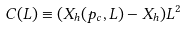<formula> <loc_0><loc_0><loc_500><loc_500>C ( L ) \equiv ( X _ { h } ( p _ { c } , L ) - X _ { h } ) L ^ { 2 }</formula> 